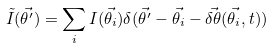Convert formula to latex. <formula><loc_0><loc_0><loc_500><loc_500>\tilde { I } ( \vec { \theta ^ { \prime } } ) = \sum _ { i } I ( \vec { \theta _ { i } } ) \delta ( \vec { \theta ^ { \prime } } - \vec { \theta _ { i } } - \vec { \delta \theta } ( \vec { \theta _ { i } } , t ) )</formula> 